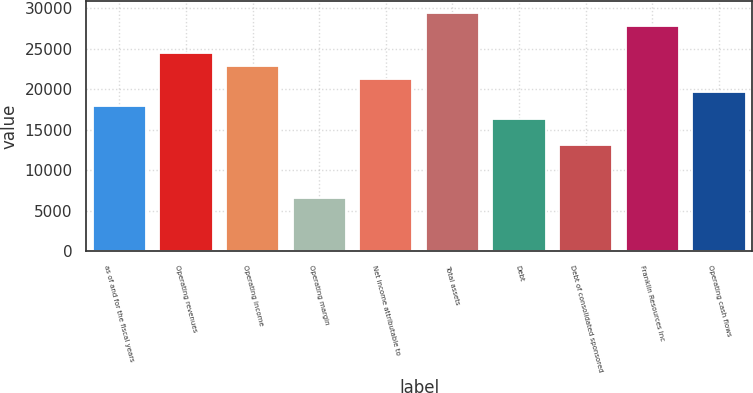<chart> <loc_0><loc_0><loc_500><loc_500><bar_chart><fcel>as of and for the fiscal years<fcel>Operating revenues<fcel>Operating income<fcel>Operating margin<fcel>Net income attributable to<fcel>Total assets<fcel>Debt<fcel>Debt of consolidated sponsored<fcel>Franklin Resources Inc<fcel>Operating cash flows<nl><fcel>17992.7<fcel>24535.4<fcel>22899.7<fcel>6543.12<fcel>21264.1<fcel>29442.4<fcel>16357.1<fcel>13085.8<fcel>27806.7<fcel>19628.4<nl></chart> 